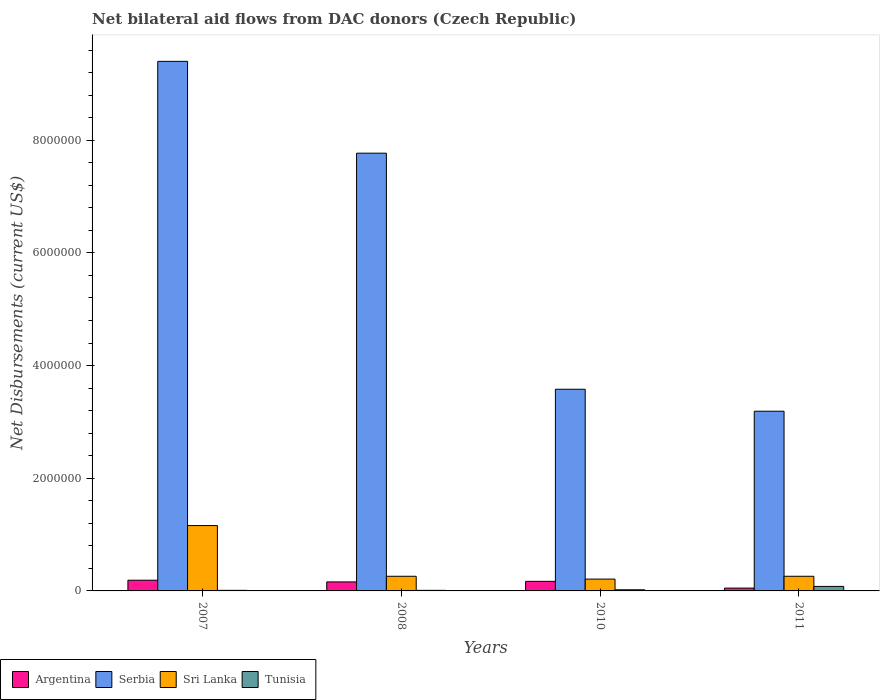How many different coloured bars are there?
Your response must be concise. 4. How many groups of bars are there?
Provide a short and direct response. 4. Are the number of bars per tick equal to the number of legend labels?
Provide a succinct answer. Yes. Are the number of bars on each tick of the X-axis equal?
Provide a short and direct response. Yes. How many bars are there on the 1st tick from the right?
Your answer should be compact. 4. What is the label of the 3rd group of bars from the left?
Your response must be concise. 2010. What is the net bilateral aid flows in Sri Lanka in 2010?
Make the answer very short. 2.10e+05. Across all years, what is the maximum net bilateral aid flows in Serbia?
Offer a terse response. 9.40e+06. Across all years, what is the minimum net bilateral aid flows in Sri Lanka?
Your response must be concise. 2.10e+05. In which year was the net bilateral aid flows in Argentina maximum?
Give a very brief answer. 2007. What is the total net bilateral aid flows in Serbia in the graph?
Your response must be concise. 2.39e+07. What is the difference between the net bilateral aid flows in Sri Lanka in 2011 and the net bilateral aid flows in Serbia in 2008?
Give a very brief answer. -7.51e+06. What is the average net bilateral aid flows in Tunisia per year?
Provide a succinct answer. 3.00e+04. What is the ratio of the net bilateral aid flows in Tunisia in 2010 to that in 2011?
Ensure brevity in your answer.  0.25. Is the difference between the net bilateral aid flows in Sri Lanka in 2007 and 2008 greater than the difference between the net bilateral aid flows in Tunisia in 2007 and 2008?
Give a very brief answer. Yes. What is the difference between the highest and the lowest net bilateral aid flows in Serbia?
Ensure brevity in your answer.  6.21e+06. In how many years, is the net bilateral aid flows in Sri Lanka greater than the average net bilateral aid flows in Sri Lanka taken over all years?
Provide a succinct answer. 1. Is the sum of the net bilateral aid flows in Argentina in 2007 and 2011 greater than the maximum net bilateral aid flows in Sri Lanka across all years?
Provide a short and direct response. No. Is it the case that in every year, the sum of the net bilateral aid flows in Serbia and net bilateral aid flows in Sri Lanka is greater than the sum of net bilateral aid flows in Tunisia and net bilateral aid flows in Argentina?
Keep it short and to the point. Yes. What does the 2nd bar from the right in 2008 represents?
Your answer should be very brief. Sri Lanka. Is it the case that in every year, the sum of the net bilateral aid flows in Tunisia and net bilateral aid flows in Argentina is greater than the net bilateral aid flows in Sri Lanka?
Offer a very short reply. No. How many bars are there?
Make the answer very short. 16. Are all the bars in the graph horizontal?
Your response must be concise. No. Does the graph contain grids?
Ensure brevity in your answer.  No. Where does the legend appear in the graph?
Your answer should be compact. Bottom left. What is the title of the graph?
Make the answer very short. Net bilateral aid flows from DAC donors (Czech Republic). What is the label or title of the Y-axis?
Give a very brief answer. Net Disbursements (current US$). What is the Net Disbursements (current US$) of Argentina in 2007?
Your response must be concise. 1.90e+05. What is the Net Disbursements (current US$) of Serbia in 2007?
Your response must be concise. 9.40e+06. What is the Net Disbursements (current US$) of Sri Lanka in 2007?
Provide a short and direct response. 1.16e+06. What is the Net Disbursements (current US$) of Tunisia in 2007?
Offer a very short reply. 10000. What is the Net Disbursements (current US$) in Serbia in 2008?
Provide a short and direct response. 7.77e+06. What is the Net Disbursements (current US$) of Argentina in 2010?
Offer a very short reply. 1.70e+05. What is the Net Disbursements (current US$) in Serbia in 2010?
Make the answer very short. 3.58e+06. What is the Net Disbursements (current US$) in Tunisia in 2010?
Ensure brevity in your answer.  2.00e+04. What is the Net Disbursements (current US$) of Serbia in 2011?
Give a very brief answer. 3.19e+06. Across all years, what is the maximum Net Disbursements (current US$) in Argentina?
Your answer should be very brief. 1.90e+05. Across all years, what is the maximum Net Disbursements (current US$) in Serbia?
Offer a terse response. 9.40e+06. Across all years, what is the maximum Net Disbursements (current US$) of Sri Lanka?
Offer a terse response. 1.16e+06. Across all years, what is the maximum Net Disbursements (current US$) in Tunisia?
Your answer should be very brief. 8.00e+04. Across all years, what is the minimum Net Disbursements (current US$) in Serbia?
Provide a succinct answer. 3.19e+06. Across all years, what is the minimum Net Disbursements (current US$) of Sri Lanka?
Keep it short and to the point. 2.10e+05. Across all years, what is the minimum Net Disbursements (current US$) in Tunisia?
Provide a succinct answer. 10000. What is the total Net Disbursements (current US$) of Argentina in the graph?
Offer a very short reply. 5.70e+05. What is the total Net Disbursements (current US$) of Serbia in the graph?
Your response must be concise. 2.39e+07. What is the total Net Disbursements (current US$) of Sri Lanka in the graph?
Offer a terse response. 1.89e+06. What is the total Net Disbursements (current US$) of Tunisia in the graph?
Your answer should be very brief. 1.20e+05. What is the difference between the Net Disbursements (current US$) in Serbia in 2007 and that in 2008?
Provide a short and direct response. 1.63e+06. What is the difference between the Net Disbursements (current US$) of Argentina in 2007 and that in 2010?
Ensure brevity in your answer.  2.00e+04. What is the difference between the Net Disbursements (current US$) in Serbia in 2007 and that in 2010?
Keep it short and to the point. 5.82e+06. What is the difference between the Net Disbursements (current US$) of Sri Lanka in 2007 and that in 2010?
Keep it short and to the point. 9.50e+05. What is the difference between the Net Disbursements (current US$) of Serbia in 2007 and that in 2011?
Offer a terse response. 6.21e+06. What is the difference between the Net Disbursements (current US$) of Argentina in 2008 and that in 2010?
Your response must be concise. -10000. What is the difference between the Net Disbursements (current US$) of Serbia in 2008 and that in 2010?
Ensure brevity in your answer.  4.19e+06. What is the difference between the Net Disbursements (current US$) in Argentina in 2008 and that in 2011?
Your answer should be compact. 1.10e+05. What is the difference between the Net Disbursements (current US$) in Serbia in 2008 and that in 2011?
Your answer should be very brief. 4.58e+06. What is the difference between the Net Disbursements (current US$) in Sri Lanka in 2008 and that in 2011?
Keep it short and to the point. 0. What is the difference between the Net Disbursements (current US$) in Tunisia in 2008 and that in 2011?
Your answer should be compact. -7.00e+04. What is the difference between the Net Disbursements (current US$) in Argentina in 2010 and that in 2011?
Offer a terse response. 1.20e+05. What is the difference between the Net Disbursements (current US$) in Tunisia in 2010 and that in 2011?
Make the answer very short. -6.00e+04. What is the difference between the Net Disbursements (current US$) in Argentina in 2007 and the Net Disbursements (current US$) in Serbia in 2008?
Your answer should be compact. -7.58e+06. What is the difference between the Net Disbursements (current US$) of Argentina in 2007 and the Net Disbursements (current US$) of Sri Lanka in 2008?
Offer a very short reply. -7.00e+04. What is the difference between the Net Disbursements (current US$) of Argentina in 2007 and the Net Disbursements (current US$) of Tunisia in 2008?
Make the answer very short. 1.80e+05. What is the difference between the Net Disbursements (current US$) in Serbia in 2007 and the Net Disbursements (current US$) in Sri Lanka in 2008?
Keep it short and to the point. 9.14e+06. What is the difference between the Net Disbursements (current US$) in Serbia in 2007 and the Net Disbursements (current US$) in Tunisia in 2008?
Make the answer very short. 9.39e+06. What is the difference between the Net Disbursements (current US$) of Sri Lanka in 2007 and the Net Disbursements (current US$) of Tunisia in 2008?
Your answer should be very brief. 1.15e+06. What is the difference between the Net Disbursements (current US$) of Argentina in 2007 and the Net Disbursements (current US$) of Serbia in 2010?
Give a very brief answer. -3.39e+06. What is the difference between the Net Disbursements (current US$) in Argentina in 2007 and the Net Disbursements (current US$) in Sri Lanka in 2010?
Give a very brief answer. -2.00e+04. What is the difference between the Net Disbursements (current US$) of Argentina in 2007 and the Net Disbursements (current US$) of Tunisia in 2010?
Offer a terse response. 1.70e+05. What is the difference between the Net Disbursements (current US$) in Serbia in 2007 and the Net Disbursements (current US$) in Sri Lanka in 2010?
Make the answer very short. 9.19e+06. What is the difference between the Net Disbursements (current US$) of Serbia in 2007 and the Net Disbursements (current US$) of Tunisia in 2010?
Offer a terse response. 9.38e+06. What is the difference between the Net Disbursements (current US$) of Sri Lanka in 2007 and the Net Disbursements (current US$) of Tunisia in 2010?
Your answer should be compact. 1.14e+06. What is the difference between the Net Disbursements (current US$) in Argentina in 2007 and the Net Disbursements (current US$) in Sri Lanka in 2011?
Ensure brevity in your answer.  -7.00e+04. What is the difference between the Net Disbursements (current US$) of Serbia in 2007 and the Net Disbursements (current US$) of Sri Lanka in 2011?
Provide a succinct answer. 9.14e+06. What is the difference between the Net Disbursements (current US$) of Serbia in 2007 and the Net Disbursements (current US$) of Tunisia in 2011?
Offer a terse response. 9.32e+06. What is the difference between the Net Disbursements (current US$) of Sri Lanka in 2007 and the Net Disbursements (current US$) of Tunisia in 2011?
Offer a terse response. 1.08e+06. What is the difference between the Net Disbursements (current US$) in Argentina in 2008 and the Net Disbursements (current US$) in Serbia in 2010?
Your response must be concise. -3.42e+06. What is the difference between the Net Disbursements (current US$) of Argentina in 2008 and the Net Disbursements (current US$) of Sri Lanka in 2010?
Your response must be concise. -5.00e+04. What is the difference between the Net Disbursements (current US$) in Serbia in 2008 and the Net Disbursements (current US$) in Sri Lanka in 2010?
Your answer should be very brief. 7.56e+06. What is the difference between the Net Disbursements (current US$) of Serbia in 2008 and the Net Disbursements (current US$) of Tunisia in 2010?
Give a very brief answer. 7.75e+06. What is the difference between the Net Disbursements (current US$) in Sri Lanka in 2008 and the Net Disbursements (current US$) in Tunisia in 2010?
Give a very brief answer. 2.40e+05. What is the difference between the Net Disbursements (current US$) in Argentina in 2008 and the Net Disbursements (current US$) in Serbia in 2011?
Offer a very short reply. -3.03e+06. What is the difference between the Net Disbursements (current US$) of Serbia in 2008 and the Net Disbursements (current US$) of Sri Lanka in 2011?
Ensure brevity in your answer.  7.51e+06. What is the difference between the Net Disbursements (current US$) in Serbia in 2008 and the Net Disbursements (current US$) in Tunisia in 2011?
Give a very brief answer. 7.69e+06. What is the difference between the Net Disbursements (current US$) of Sri Lanka in 2008 and the Net Disbursements (current US$) of Tunisia in 2011?
Your answer should be very brief. 1.80e+05. What is the difference between the Net Disbursements (current US$) of Argentina in 2010 and the Net Disbursements (current US$) of Serbia in 2011?
Provide a succinct answer. -3.02e+06. What is the difference between the Net Disbursements (current US$) in Serbia in 2010 and the Net Disbursements (current US$) in Sri Lanka in 2011?
Your answer should be compact. 3.32e+06. What is the difference between the Net Disbursements (current US$) of Serbia in 2010 and the Net Disbursements (current US$) of Tunisia in 2011?
Ensure brevity in your answer.  3.50e+06. What is the difference between the Net Disbursements (current US$) in Sri Lanka in 2010 and the Net Disbursements (current US$) in Tunisia in 2011?
Provide a short and direct response. 1.30e+05. What is the average Net Disbursements (current US$) of Argentina per year?
Offer a very short reply. 1.42e+05. What is the average Net Disbursements (current US$) in Serbia per year?
Provide a succinct answer. 5.98e+06. What is the average Net Disbursements (current US$) in Sri Lanka per year?
Your answer should be very brief. 4.72e+05. In the year 2007, what is the difference between the Net Disbursements (current US$) in Argentina and Net Disbursements (current US$) in Serbia?
Provide a short and direct response. -9.21e+06. In the year 2007, what is the difference between the Net Disbursements (current US$) of Argentina and Net Disbursements (current US$) of Sri Lanka?
Your response must be concise. -9.70e+05. In the year 2007, what is the difference between the Net Disbursements (current US$) of Argentina and Net Disbursements (current US$) of Tunisia?
Provide a succinct answer. 1.80e+05. In the year 2007, what is the difference between the Net Disbursements (current US$) of Serbia and Net Disbursements (current US$) of Sri Lanka?
Provide a short and direct response. 8.24e+06. In the year 2007, what is the difference between the Net Disbursements (current US$) in Serbia and Net Disbursements (current US$) in Tunisia?
Your answer should be very brief. 9.39e+06. In the year 2007, what is the difference between the Net Disbursements (current US$) in Sri Lanka and Net Disbursements (current US$) in Tunisia?
Offer a terse response. 1.15e+06. In the year 2008, what is the difference between the Net Disbursements (current US$) of Argentina and Net Disbursements (current US$) of Serbia?
Give a very brief answer. -7.61e+06. In the year 2008, what is the difference between the Net Disbursements (current US$) of Argentina and Net Disbursements (current US$) of Tunisia?
Keep it short and to the point. 1.50e+05. In the year 2008, what is the difference between the Net Disbursements (current US$) of Serbia and Net Disbursements (current US$) of Sri Lanka?
Offer a very short reply. 7.51e+06. In the year 2008, what is the difference between the Net Disbursements (current US$) in Serbia and Net Disbursements (current US$) in Tunisia?
Your answer should be compact. 7.76e+06. In the year 2008, what is the difference between the Net Disbursements (current US$) of Sri Lanka and Net Disbursements (current US$) of Tunisia?
Your answer should be very brief. 2.50e+05. In the year 2010, what is the difference between the Net Disbursements (current US$) in Argentina and Net Disbursements (current US$) in Serbia?
Ensure brevity in your answer.  -3.41e+06. In the year 2010, what is the difference between the Net Disbursements (current US$) of Argentina and Net Disbursements (current US$) of Sri Lanka?
Provide a short and direct response. -4.00e+04. In the year 2010, what is the difference between the Net Disbursements (current US$) in Argentina and Net Disbursements (current US$) in Tunisia?
Your answer should be very brief. 1.50e+05. In the year 2010, what is the difference between the Net Disbursements (current US$) of Serbia and Net Disbursements (current US$) of Sri Lanka?
Offer a terse response. 3.37e+06. In the year 2010, what is the difference between the Net Disbursements (current US$) of Serbia and Net Disbursements (current US$) of Tunisia?
Ensure brevity in your answer.  3.56e+06. In the year 2010, what is the difference between the Net Disbursements (current US$) in Sri Lanka and Net Disbursements (current US$) in Tunisia?
Give a very brief answer. 1.90e+05. In the year 2011, what is the difference between the Net Disbursements (current US$) in Argentina and Net Disbursements (current US$) in Serbia?
Ensure brevity in your answer.  -3.14e+06. In the year 2011, what is the difference between the Net Disbursements (current US$) in Serbia and Net Disbursements (current US$) in Sri Lanka?
Your answer should be compact. 2.93e+06. In the year 2011, what is the difference between the Net Disbursements (current US$) of Serbia and Net Disbursements (current US$) of Tunisia?
Your response must be concise. 3.11e+06. What is the ratio of the Net Disbursements (current US$) of Argentina in 2007 to that in 2008?
Keep it short and to the point. 1.19. What is the ratio of the Net Disbursements (current US$) of Serbia in 2007 to that in 2008?
Provide a short and direct response. 1.21. What is the ratio of the Net Disbursements (current US$) in Sri Lanka in 2007 to that in 2008?
Provide a short and direct response. 4.46. What is the ratio of the Net Disbursements (current US$) of Tunisia in 2007 to that in 2008?
Keep it short and to the point. 1. What is the ratio of the Net Disbursements (current US$) of Argentina in 2007 to that in 2010?
Provide a succinct answer. 1.12. What is the ratio of the Net Disbursements (current US$) of Serbia in 2007 to that in 2010?
Your answer should be very brief. 2.63. What is the ratio of the Net Disbursements (current US$) of Sri Lanka in 2007 to that in 2010?
Your answer should be compact. 5.52. What is the ratio of the Net Disbursements (current US$) of Argentina in 2007 to that in 2011?
Ensure brevity in your answer.  3.8. What is the ratio of the Net Disbursements (current US$) in Serbia in 2007 to that in 2011?
Offer a terse response. 2.95. What is the ratio of the Net Disbursements (current US$) of Sri Lanka in 2007 to that in 2011?
Give a very brief answer. 4.46. What is the ratio of the Net Disbursements (current US$) in Argentina in 2008 to that in 2010?
Your answer should be very brief. 0.94. What is the ratio of the Net Disbursements (current US$) of Serbia in 2008 to that in 2010?
Your answer should be very brief. 2.17. What is the ratio of the Net Disbursements (current US$) of Sri Lanka in 2008 to that in 2010?
Keep it short and to the point. 1.24. What is the ratio of the Net Disbursements (current US$) in Tunisia in 2008 to that in 2010?
Give a very brief answer. 0.5. What is the ratio of the Net Disbursements (current US$) of Argentina in 2008 to that in 2011?
Offer a terse response. 3.2. What is the ratio of the Net Disbursements (current US$) in Serbia in 2008 to that in 2011?
Make the answer very short. 2.44. What is the ratio of the Net Disbursements (current US$) of Argentina in 2010 to that in 2011?
Provide a short and direct response. 3.4. What is the ratio of the Net Disbursements (current US$) of Serbia in 2010 to that in 2011?
Provide a short and direct response. 1.12. What is the ratio of the Net Disbursements (current US$) of Sri Lanka in 2010 to that in 2011?
Keep it short and to the point. 0.81. What is the ratio of the Net Disbursements (current US$) in Tunisia in 2010 to that in 2011?
Offer a terse response. 0.25. What is the difference between the highest and the second highest Net Disbursements (current US$) in Argentina?
Your answer should be compact. 2.00e+04. What is the difference between the highest and the second highest Net Disbursements (current US$) in Serbia?
Your response must be concise. 1.63e+06. What is the difference between the highest and the second highest Net Disbursements (current US$) in Sri Lanka?
Your answer should be compact. 9.00e+05. What is the difference between the highest and the lowest Net Disbursements (current US$) of Argentina?
Offer a very short reply. 1.40e+05. What is the difference between the highest and the lowest Net Disbursements (current US$) in Serbia?
Your answer should be very brief. 6.21e+06. What is the difference between the highest and the lowest Net Disbursements (current US$) of Sri Lanka?
Make the answer very short. 9.50e+05. 